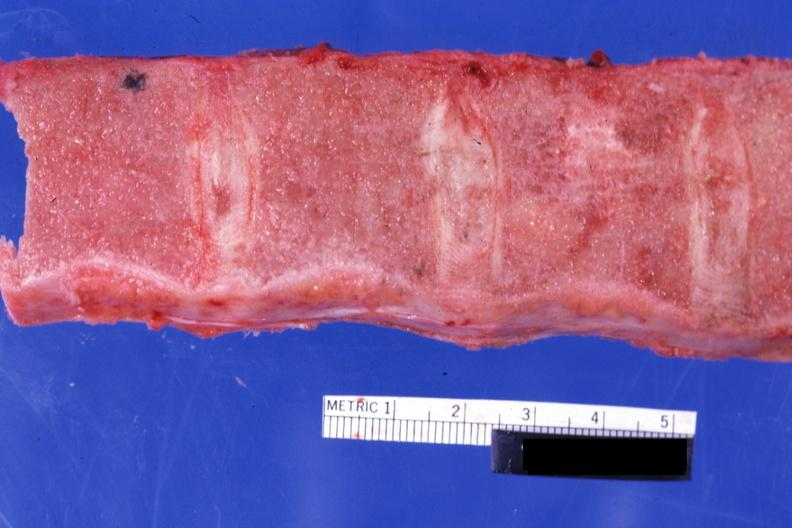s bone marrow present?
Answer the question using a single word or phrase. Yes 